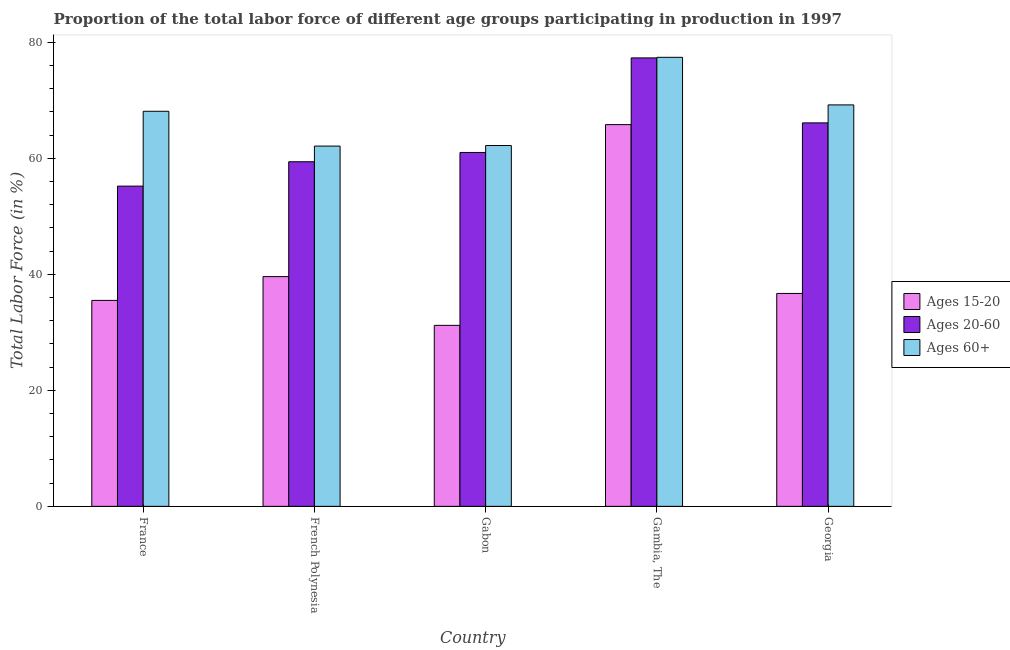How many different coloured bars are there?
Offer a terse response. 3. How many groups of bars are there?
Keep it short and to the point. 5. Are the number of bars per tick equal to the number of legend labels?
Your answer should be very brief. Yes. Are the number of bars on each tick of the X-axis equal?
Give a very brief answer. Yes. How many bars are there on the 3rd tick from the left?
Give a very brief answer. 3. How many bars are there on the 3rd tick from the right?
Offer a very short reply. 3. What is the label of the 4th group of bars from the left?
Give a very brief answer. Gambia, The. What is the percentage of labor force within the age group 20-60 in Gambia, The?
Provide a succinct answer. 77.3. Across all countries, what is the maximum percentage of labor force above age 60?
Make the answer very short. 77.4. Across all countries, what is the minimum percentage of labor force within the age group 20-60?
Your response must be concise. 55.2. In which country was the percentage of labor force within the age group 20-60 maximum?
Provide a short and direct response. Gambia, The. In which country was the percentage of labor force within the age group 15-20 minimum?
Offer a very short reply. Gabon. What is the total percentage of labor force within the age group 15-20 in the graph?
Offer a very short reply. 208.8. What is the difference between the percentage of labor force within the age group 20-60 in France and that in Gabon?
Your answer should be very brief. -5.8. What is the difference between the percentage of labor force above age 60 in Georgia and the percentage of labor force within the age group 15-20 in Gabon?
Ensure brevity in your answer.  38. What is the average percentage of labor force within the age group 15-20 per country?
Your answer should be compact. 41.76. What is the difference between the percentage of labor force above age 60 and percentage of labor force within the age group 20-60 in Georgia?
Offer a very short reply. 3.1. What is the ratio of the percentage of labor force above age 60 in France to that in French Polynesia?
Offer a very short reply. 1.1. Is the percentage of labor force above age 60 in France less than that in Gambia, The?
Make the answer very short. Yes. Is the difference between the percentage of labor force within the age group 15-20 in France and French Polynesia greater than the difference between the percentage of labor force within the age group 20-60 in France and French Polynesia?
Provide a succinct answer. Yes. What is the difference between the highest and the second highest percentage of labor force above age 60?
Provide a short and direct response. 8.2. What is the difference between the highest and the lowest percentage of labor force above age 60?
Make the answer very short. 15.3. In how many countries, is the percentage of labor force within the age group 15-20 greater than the average percentage of labor force within the age group 15-20 taken over all countries?
Make the answer very short. 1. Is the sum of the percentage of labor force within the age group 15-20 in Gabon and Georgia greater than the maximum percentage of labor force within the age group 20-60 across all countries?
Provide a short and direct response. No. What does the 1st bar from the left in Gabon represents?
Make the answer very short. Ages 15-20. What does the 2nd bar from the right in French Polynesia represents?
Offer a terse response. Ages 20-60. Is it the case that in every country, the sum of the percentage of labor force within the age group 15-20 and percentage of labor force within the age group 20-60 is greater than the percentage of labor force above age 60?
Make the answer very short. Yes. How many bars are there?
Your answer should be very brief. 15. Are all the bars in the graph horizontal?
Your response must be concise. No. What is the difference between two consecutive major ticks on the Y-axis?
Give a very brief answer. 20. What is the title of the graph?
Provide a succinct answer. Proportion of the total labor force of different age groups participating in production in 1997. Does "Natural gas sources" appear as one of the legend labels in the graph?
Provide a short and direct response. No. What is the label or title of the Y-axis?
Make the answer very short. Total Labor Force (in %). What is the Total Labor Force (in %) of Ages 15-20 in France?
Offer a terse response. 35.5. What is the Total Labor Force (in %) in Ages 20-60 in France?
Your answer should be compact. 55.2. What is the Total Labor Force (in %) in Ages 60+ in France?
Your answer should be very brief. 68.1. What is the Total Labor Force (in %) in Ages 15-20 in French Polynesia?
Your answer should be very brief. 39.6. What is the Total Labor Force (in %) in Ages 20-60 in French Polynesia?
Keep it short and to the point. 59.4. What is the Total Labor Force (in %) of Ages 60+ in French Polynesia?
Provide a succinct answer. 62.1. What is the Total Labor Force (in %) of Ages 15-20 in Gabon?
Provide a short and direct response. 31.2. What is the Total Labor Force (in %) of Ages 20-60 in Gabon?
Make the answer very short. 61. What is the Total Labor Force (in %) in Ages 60+ in Gabon?
Provide a succinct answer. 62.2. What is the Total Labor Force (in %) in Ages 15-20 in Gambia, The?
Provide a succinct answer. 65.8. What is the Total Labor Force (in %) in Ages 20-60 in Gambia, The?
Keep it short and to the point. 77.3. What is the Total Labor Force (in %) of Ages 60+ in Gambia, The?
Your response must be concise. 77.4. What is the Total Labor Force (in %) of Ages 15-20 in Georgia?
Provide a short and direct response. 36.7. What is the Total Labor Force (in %) in Ages 20-60 in Georgia?
Your answer should be compact. 66.1. What is the Total Labor Force (in %) of Ages 60+ in Georgia?
Your response must be concise. 69.2. Across all countries, what is the maximum Total Labor Force (in %) of Ages 15-20?
Ensure brevity in your answer.  65.8. Across all countries, what is the maximum Total Labor Force (in %) of Ages 20-60?
Your response must be concise. 77.3. Across all countries, what is the maximum Total Labor Force (in %) of Ages 60+?
Your answer should be compact. 77.4. Across all countries, what is the minimum Total Labor Force (in %) in Ages 15-20?
Your answer should be compact. 31.2. Across all countries, what is the minimum Total Labor Force (in %) in Ages 20-60?
Keep it short and to the point. 55.2. Across all countries, what is the minimum Total Labor Force (in %) of Ages 60+?
Your answer should be compact. 62.1. What is the total Total Labor Force (in %) of Ages 15-20 in the graph?
Provide a short and direct response. 208.8. What is the total Total Labor Force (in %) in Ages 20-60 in the graph?
Your answer should be very brief. 319. What is the total Total Labor Force (in %) of Ages 60+ in the graph?
Your answer should be compact. 339. What is the difference between the Total Labor Force (in %) of Ages 20-60 in France and that in Gabon?
Ensure brevity in your answer.  -5.8. What is the difference between the Total Labor Force (in %) in Ages 60+ in France and that in Gabon?
Provide a short and direct response. 5.9. What is the difference between the Total Labor Force (in %) of Ages 15-20 in France and that in Gambia, The?
Keep it short and to the point. -30.3. What is the difference between the Total Labor Force (in %) of Ages 20-60 in France and that in Gambia, The?
Give a very brief answer. -22.1. What is the difference between the Total Labor Force (in %) of Ages 60+ in France and that in Gambia, The?
Your response must be concise. -9.3. What is the difference between the Total Labor Force (in %) in Ages 15-20 in France and that in Georgia?
Keep it short and to the point. -1.2. What is the difference between the Total Labor Force (in %) of Ages 15-20 in French Polynesia and that in Gabon?
Offer a terse response. 8.4. What is the difference between the Total Labor Force (in %) in Ages 20-60 in French Polynesia and that in Gabon?
Provide a succinct answer. -1.6. What is the difference between the Total Labor Force (in %) of Ages 15-20 in French Polynesia and that in Gambia, The?
Offer a terse response. -26.2. What is the difference between the Total Labor Force (in %) of Ages 20-60 in French Polynesia and that in Gambia, The?
Make the answer very short. -17.9. What is the difference between the Total Labor Force (in %) in Ages 60+ in French Polynesia and that in Gambia, The?
Make the answer very short. -15.3. What is the difference between the Total Labor Force (in %) in Ages 15-20 in French Polynesia and that in Georgia?
Offer a very short reply. 2.9. What is the difference between the Total Labor Force (in %) of Ages 20-60 in French Polynesia and that in Georgia?
Provide a short and direct response. -6.7. What is the difference between the Total Labor Force (in %) in Ages 60+ in French Polynesia and that in Georgia?
Offer a very short reply. -7.1. What is the difference between the Total Labor Force (in %) in Ages 15-20 in Gabon and that in Gambia, The?
Your response must be concise. -34.6. What is the difference between the Total Labor Force (in %) of Ages 20-60 in Gabon and that in Gambia, The?
Offer a terse response. -16.3. What is the difference between the Total Labor Force (in %) in Ages 60+ in Gabon and that in Gambia, The?
Your answer should be compact. -15.2. What is the difference between the Total Labor Force (in %) in Ages 20-60 in Gabon and that in Georgia?
Make the answer very short. -5.1. What is the difference between the Total Labor Force (in %) of Ages 60+ in Gabon and that in Georgia?
Provide a succinct answer. -7. What is the difference between the Total Labor Force (in %) of Ages 15-20 in Gambia, The and that in Georgia?
Offer a very short reply. 29.1. What is the difference between the Total Labor Force (in %) of Ages 20-60 in Gambia, The and that in Georgia?
Your response must be concise. 11.2. What is the difference between the Total Labor Force (in %) of Ages 60+ in Gambia, The and that in Georgia?
Ensure brevity in your answer.  8.2. What is the difference between the Total Labor Force (in %) of Ages 15-20 in France and the Total Labor Force (in %) of Ages 20-60 in French Polynesia?
Your answer should be compact. -23.9. What is the difference between the Total Labor Force (in %) in Ages 15-20 in France and the Total Labor Force (in %) in Ages 60+ in French Polynesia?
Ensure brevity in your answer.  -26.6. What is the difference between the Total Labor Force (in %) in Ages 15-20 in France and the Total Labor Force (in %) in Ages 20-60 in Gabon?
Offer a very short reply. -25.5. What is the difference between the Total Labor Force (in %) in Ages 15-20 in France and the Total Labor Force (in %) in Ages 60+ in Gabon?
Offer a terse response. -26.7. What is the difference between the Total Labor Force (in %) in Ages 15-20 in France and the Total Labor Force (in %) in Ages 20-60 in Gambia, The?
Keep it short and to the point. -41.8. What is the difference between the Total Labor Force (in %) of Ages 15-20 in France and the Total Labor Force (in %) of Ages 60+ in Gambia, The?
Give a very brief answer. -41.9. What is the difference between the Total Labor Force (in %) of Ages 20-60 in France and the Total Labor Force (in %) of Ages 60+ in Gambia, The?
Provide a short and direct response. -22.2. What is the difference between the Total Labor Force (in %) of Ages 15-20 in France and the Total Labor Force (in %) of Ages 20-60 in Georgia?
Offer a very short reply. -30.6. What is the difference between the Total Labor Force (in %) in Ages 15-20 in France and the Total Labor Force (in %) in Ages 60+ in Georgia?
Make the answer very short. -33.7. What is the difference between the Total Labor Force (in %) of Ages 15-20 in French Polynesia and the Total Labor Force (in %) of Ages 20-60 in Gabon?
Make the answer very short. -21.4. What is the difference between the Total Labor Force (in %) of Ages 15-20 in French Polynesia and the Total Labor Force (in %) of Ages 60+ in Gabon?
Make the answer very short. -22.6. What is the difference between the Total Labor Force (in %) of Ages 20-60 in French Polynesia and the Total Labor Force (in %) of Ages 60+ in Gabon?
Your response must be concise. -2.8. What is the difference between the Total Labor Force (in %) in Ages 15-20 in French Polynesia and the Total Labor Force (in %) in Ages 20-60 in Gambia, The?
Offer a terse response. -37.7. What is the difference between the Total Labor Force (in %) of Ages 15-20 in French Polynesia and the Total Labor Force (in %) of Ages 60+ in Gambia, The?
Your response must be concise. -37.8. What is the difference between the Total Labor Force (in %) in Ages 20-60 in French Polynesia and the Total Labor Force (in %) in Ages 60+ in Gambia, The?
Your response must be concise. -18. What is the difference between the Total Labor Force (in %) in Ages 15-20 in French Polynesia and the Total Labor Force (in %) in Ages 20-60 in Georgia?
Keep it short and to the point. -26.5. What is the difference between the Total Labor Force (in %) of Ages 15-20 in French Polynesia and the Total Labor Force (in %) of Ages 60+ in Georgia?
Your answer should be very brief. -29.6. What is the difference between the Total Labor Force (in %) in Ages 15-20 in Gabon and the Total Labor Force (in %) in Ages 20-60 in Gambia, The?
Your response must be concise. -46.1. What is the difference between the Total Labor Force (in %) of Ages 15-20 in Gabon and the Total Labor Force (in %) of Ages 60+ in Gambia, The?
Make the answer very short. -46.2. What is the difference between the Total Labor Force (in %) in Ages 20-60 in Gabon and the Total Labor Force (in %) in Ages 60+ in Gambia, The?
Offer a very short reply. -16.4. What is the difference between the Total Labor Force (in %) in Ages 15-20 in Gabon and the Total Labor Force (in %) in Ages 20-60 in Georgia?
Offer a very short reply. -34.9. What is the difference between the Total Labor Force (in %) of Ages 15-20 in Gabon and the Total Labor Force (in %) of Ages 60+ in Georgia?
Your answer should be compact. -38. What is the difference between the Total Labor Force (in %) in Ages 20-60 in Gabon and the Total Labor Force (in %) in Ages 60+ in Georgia?
Make the answer very short. -8.2. What is the average Total Labor Force (in %) in Ages 15-20 per country?
Make the answer very short. 41.76. What is the average Total Labor Force (in %) in Ages 20-60 per country?
Provide a succinct answer. 63.8. What is the average Total Labor Force (in %) in Ages 60+ per country?
Ensure brevity in your answer.  67.8. What is the difference between the Total Labor Force (in %) in Ages 15-20 and Total Labor Force (in %) in Ages 20-60 in France?
Offer a terse response. -19.7. What is the difference between the Total Labor Force (in %) of Ages 15-20 and Total Labor Force (in %) of Ages 60+ in France?
Offer a very short reply. -32.6. What is the difference between the Total Labor Force (in %) of Ages 15-20 and Total Labor Force (in %) of Ages 20-60 in French Polynesia?
Provide a succinct answer. -19.8. What is the difference between the Total Labor Force (in %) of Ages 15-20 and Total Labor Force (in %) of Ages 60+ in French Polynesia?
Your answer should be very brief. -22.5. What is the difference between the Total Labor Force (in %) of Ages 15-20 and Total Labor Force (in %) of Ages 20-60 in Gabon?
Provide a succinct answer. -29.8. What is the difference between the Total Labor Force (in %) of Ages 15-20 and Total Labor Force (in %) of Ages 60+ in Gabon?
Provide a succinct answer. -31. What is the difference between the Total Labor Force (in %) of Ages 20-60 and Total Labor Force (in %) of Ages 60+ in Gabon?
Offer a very short reply. -1.2. What is the difference between the Total Labor Force (in %) in Ages 15-20 and Total Labor Force (in %) in Ages 60+ in Gambia, The?
Keep it short and to the point. -11.6. What is the difference between the Total Labor Force (in %) of Ages 15-20 and Total Labor Force (in %) of Ages 20-60 in Georgia?
Make the answer very short. -29.4. What is the difference between the Total Labor Force (in %) of Ages 15-20 and Total Labor Force (in %) of Ages 60+ in Georgia?
Provide a short and direct response. -32.5. What is the difference between the Total Labor Force (in %) in Ages 20-60 and Total Labor Force (in %) in Ages 60+ in Georgia?
Provide a short and direct response. -3.1. What is the ratio of the Total Labor Force (in %) in Ages 15-20 in France to that in French Polynesia?
Your answer should be very brief. 0.9. What is the ratio of the Total Labor Force (in %) of Ages 20-60 in France to that in French Polynesia?
Make the answer very short. 0.93. What is the ratio of the Total Labor Force (in %) of Ages 60+ in France to that in French Polynesia?
Make the answer very short. 1.1. What is the ratio of the Total Labor Force (in %) of Ages 15-20 in France to that in Gabon?
Provide a short and direct response. 1.14. What is the ratio of the Total Labor Force (in %) of Ages 20-60 in France to that in Gabon?
Your response must be concise. 0.9. What is the ratio of the Total Labor Force (in %) in Ages 60+ in France to that in Gabon?
Ensure brevity in your answer.  1.09. What is the ratio of the Total Labor Force (in %) in Ages 15-20 in France to that in Gambia, The?
Offer a very short reply. 0.54. What is the ratio of the Total Labor Force (in %) in Ages 20-60 in France to that in Gambia, The?
Make the answer very short. 0.71. What is the ratio of the Total Labor Force (in %) of Ages 60+ in France to that in Gambia, The?
Offer a terse response. 0.88. What is the ratio of the Total Labor Force (in %) in Ages 15-20 in France to that in Georgia?
Provide a short and direct response. 0.97. What is the ratio of the Total Labor Force (in %) in Ages 20-60 in France to that in Georgia?
Make the answer very short. 0.84. What is the ratio of the Total Labor Force (in %) in Ages 60+ in France to that in Georgia?
Offer a terse response. 0.98. What is the ratio of the Total Labor Force (in %) of Ages 15-20 in French Polynesia to that in Gabon?
Make the answer very short. 1.27. What is the ratio of the Total Labor Force (in %) of Ages 20-60 in French Polynesia to that in Gabon?
Your answer should be very brief. 0.97. What is the ratio of the Total Labor Force (in %) of Ages 60+ in French Polynesia to that in Gabon?
Your response must be concise. 1. What is the ratio of the Total Labor Force (in %) in Ages 15-20 in French Polynesia to that in Gambia, The?
Your answer should be compact. 0.6. What is the ratio of the Total Labor Force (in %) in Ages 20-60 in French Polynesia to that in Gambia, The?
Make the answer very short. 0.77. What is the ratio of the Total Labor Force (in %) of Ages 60+ in French Polynesia to that in Gambia, The?
Provide a short and direct response. 0.8. What is the ratio of the Total Labor Force (in %) in Ages 15-20 in French Polynesia to that in Georgia?
Keep it short and to the point. 1.08. What is the ratio of the Total Labor Force (in %) of Ages 20-60 in French Polynesia to that in Georgia?
Your answer should be very brief. 0.9. What is the ratio of the Total Labor Force (in %) of Ages 60+ in French Polynesia to that in Georgia?
Ensure brevity in your answer.  0.9. What is the ratio of the Total Labor Force (in %) in Ages 15-20 in Gabon to that in Gambia, The?
Provide a succinct answer. 0.47. What is the ratio of the Total Labor Force (in %) in Ages 20-60 in Gabon to that in Gambia, The?
Keep it short and to the point. 0.79. What is the ratio of the Total Labor Force (in %) in Ages 60+ in Gabon to that in Gambia, The?
Provide a succinct answer. 0.8. What is the ratio of the Total Labor Force (in %) of Ages 15-20 in Gabon to that in Georgia?
Ensure brevity in your answer.  0.85. What is the ratio of the Total Labor Force (in %) in Ages 20-60 in Gabon to that in Georgia?
Give a very brief answer. 0.92. What is the ratio of the Total Labor Force (in %) in Ages 60+ in Gabon to that in Georgia?
Offer a terse response. 0.9. What is the ratio of the Total Labor Force (in %) of Ages 15-20 in Gambia, The to that in Georgia?
Provide a short and direct response. 1.79. What is the ratio of the Total Labor Force (in %) in Ages 20-60 in Gambia, The to that in Georgia?
Your answer should be compact. 1.17. What is the ratio of the Total Labor Force (in %) of Ages 60+ in Gambia, The to that in Georgia?
Your answer should be compact. 1.12. What is the difference between the highest and the second highest Total Labor Force (in %) of Ages 15-20?
Your answer should be compact. 26.2. What is the difference between the highest and the lowest Total Labor Force (in %) of Ages 15-20?
Give a very brief answer. 34.6. What is the difference between the highest and the lowest Total Labor Force (in %) of Ages 20-60?
Offer a very short reply. 22.1. What is the difference between the highest and the lowest Total Labor Force (in %) in Ages 60+?
Offer a very short reply. 15.3. 